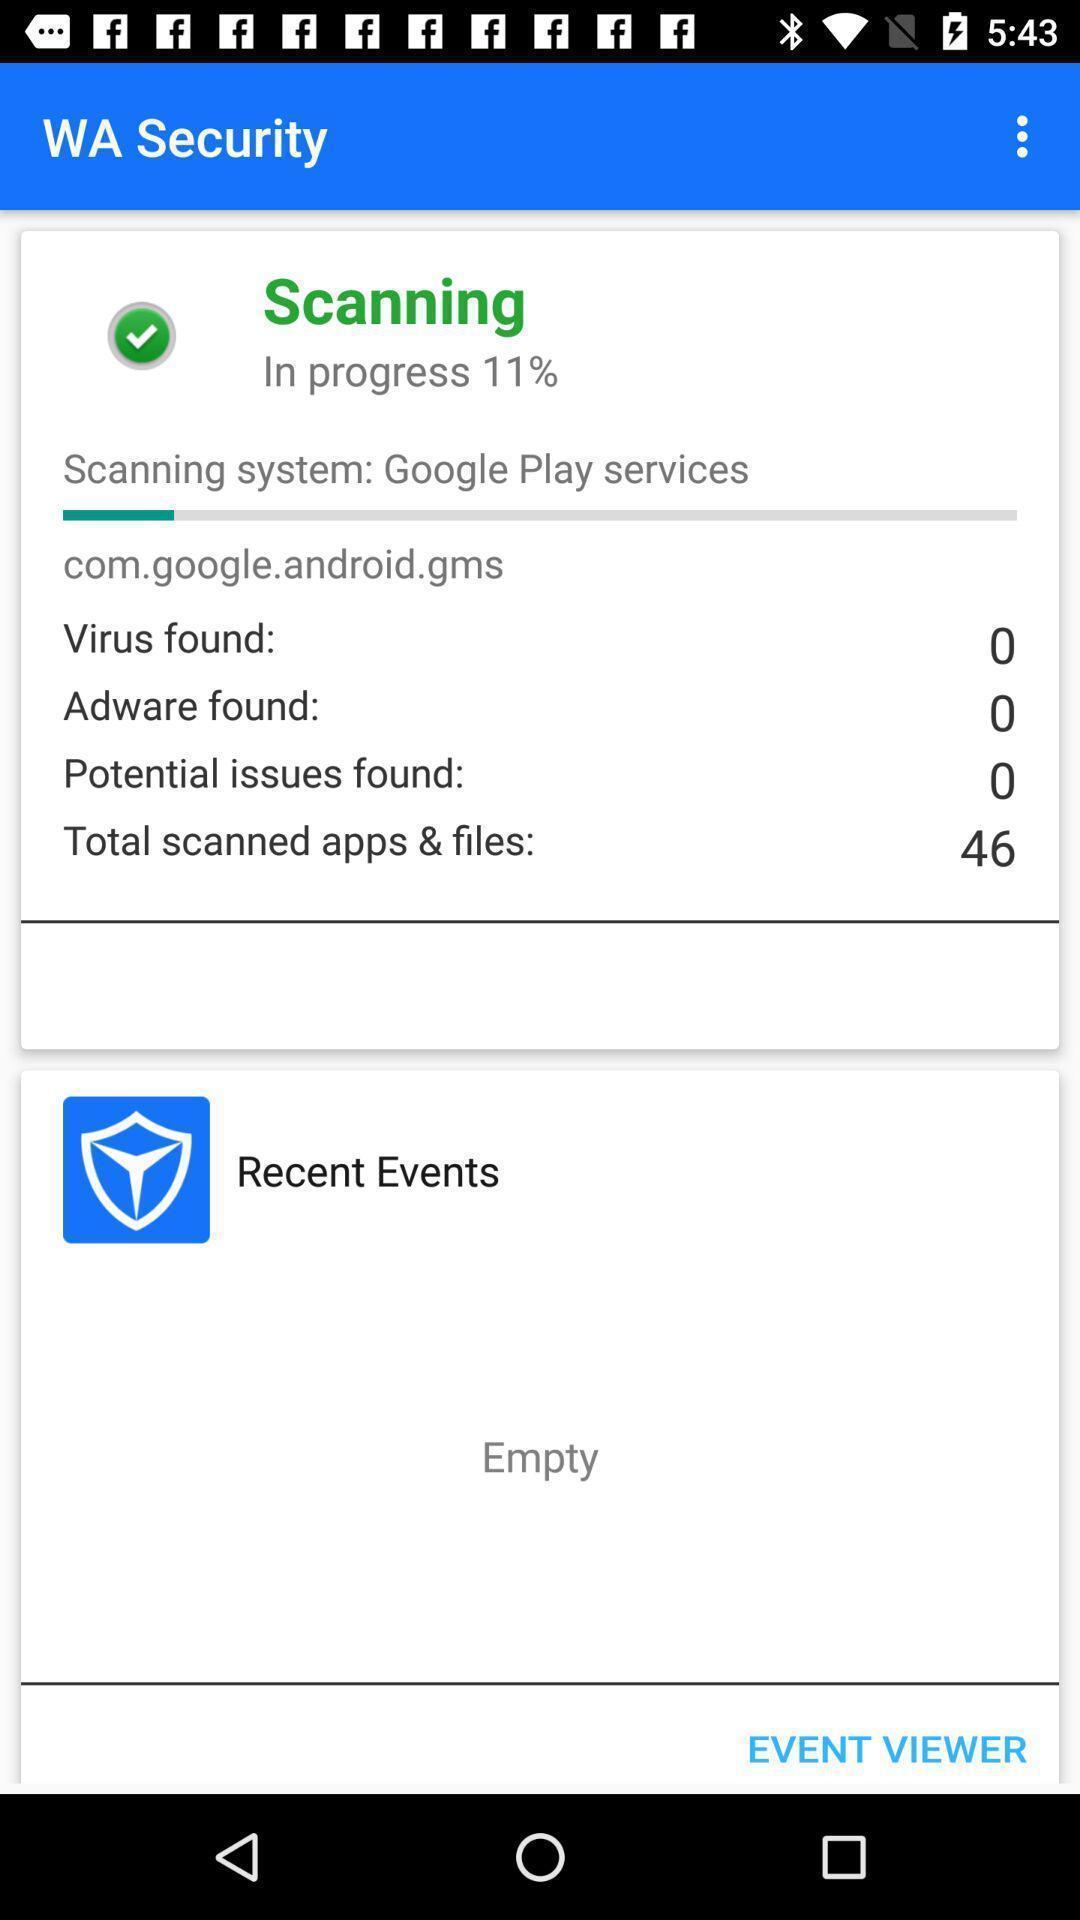What is the overall content of this screenshot? Screen shows a scanner progressing. 